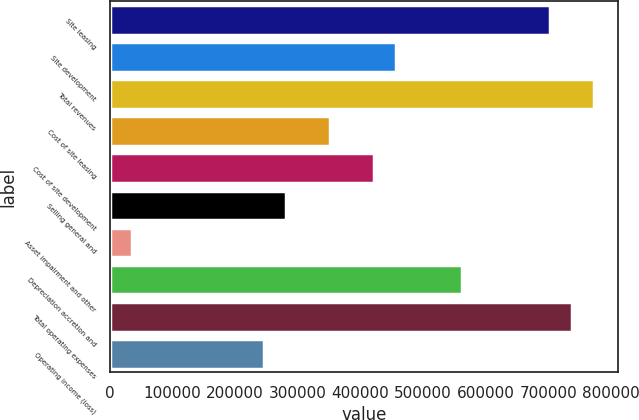<chart> <loc_0><loc_0><loc_500><loc_500><bar_chart><fcel>Site leasing<fcel>Site development<fcel>Total revenues<fcel>Cost of site leasing<fcel>Cost of site development<fcel>Selling general and<fcel>Asset impairment and other<fcel>Depreciation accretion and<fcel>Total operating expenses<fcel>Operating income (loss)<nl><fcel>702203<fcel>456432<fcel>772423<fcel>351102<fcel>421322<fcel>280882<fcel>35111.4<fcel>561762<fcel>737313<fcel>245772<nl></chart> 